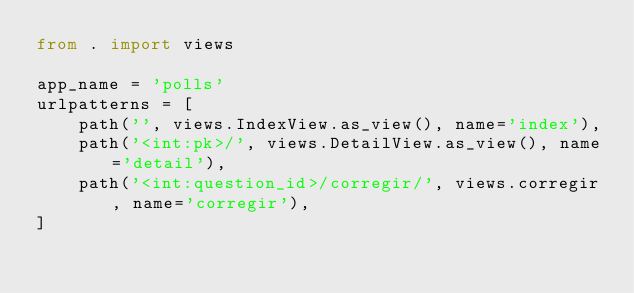Convert code to text. <code><loc_0><loc_0><loc_500><loc_500><_Python_>from . import views

app_name = 'polls'
urlpatterns = [
    path('', views.IndexView.as_view(), name='index'),
    path('<int:pk>/', views.DetailView.as_view(), name='detail'),
	path('<int:question_id>/corregir/', views.corregir, name='corregir'),    
]
</code> 